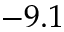Convert formula to latex. <formula><loc_0><loc_0><loc_500><loc_500>- 9 . 1</formula> 